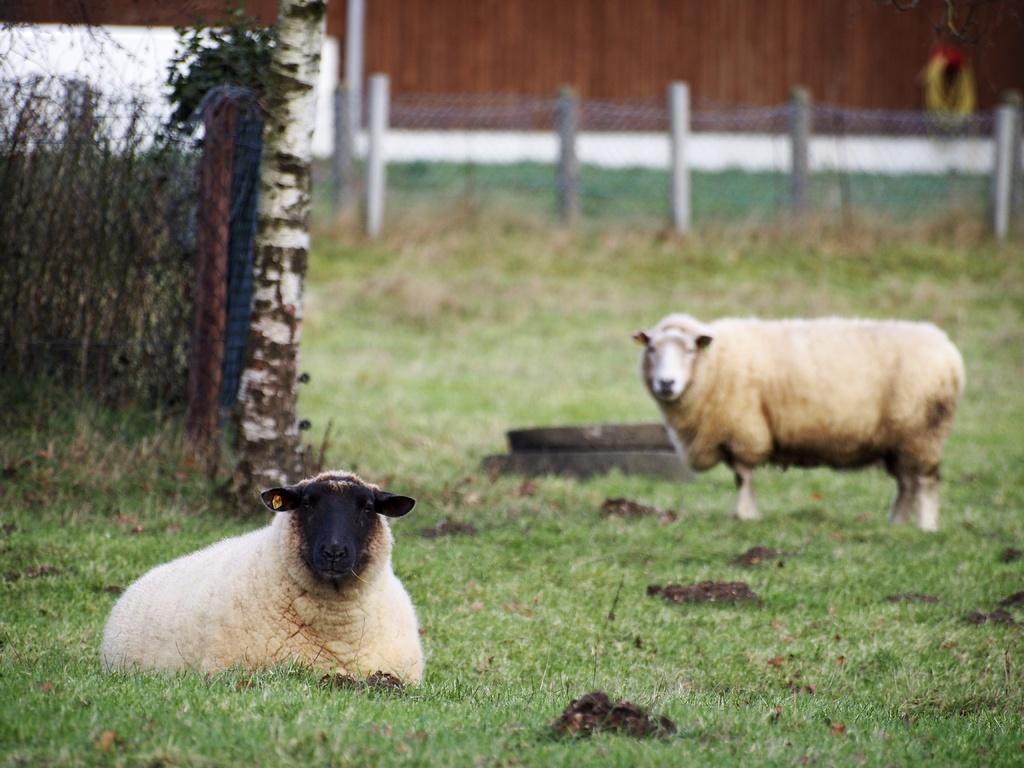How would you summarize this image in a sentence or two? In this image we can see two sheep on the grass. In the background, we can see the metal fencing. 